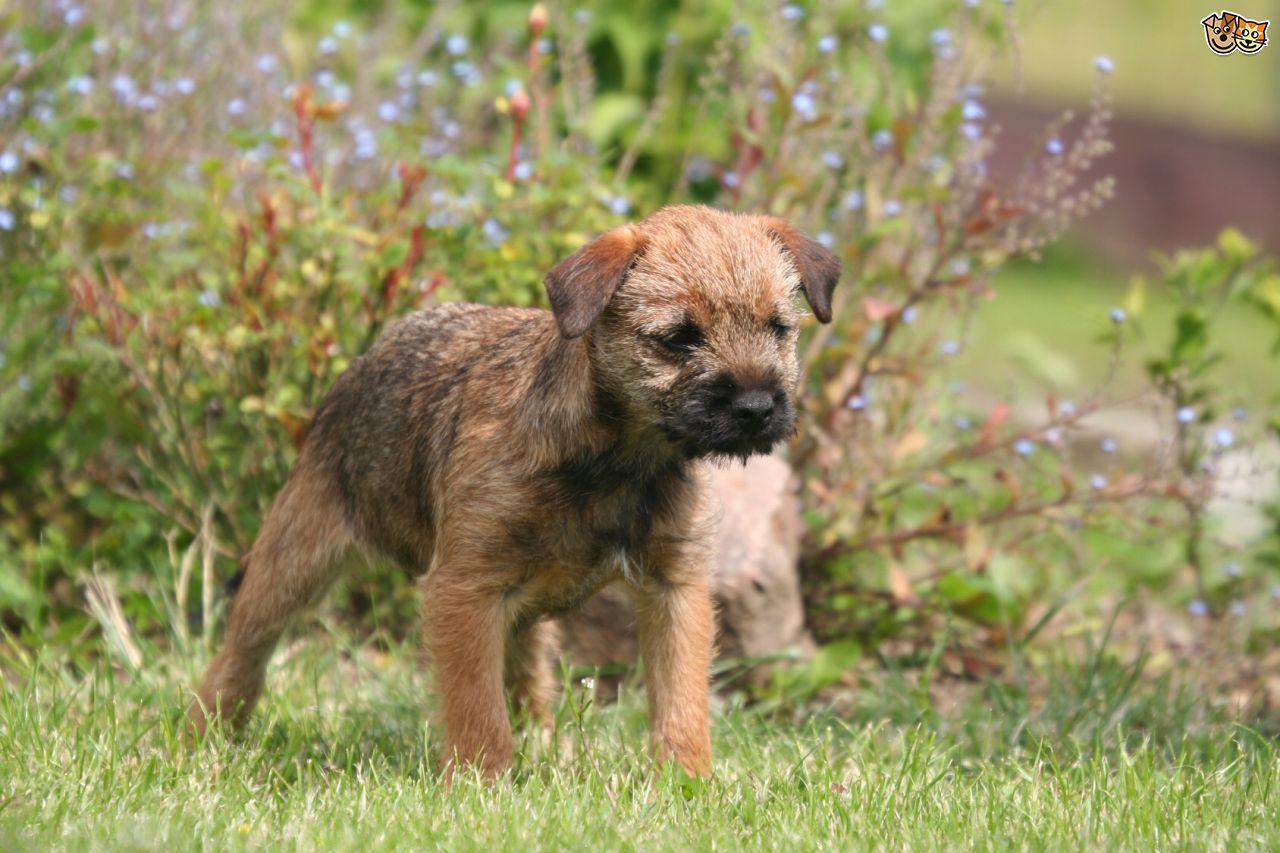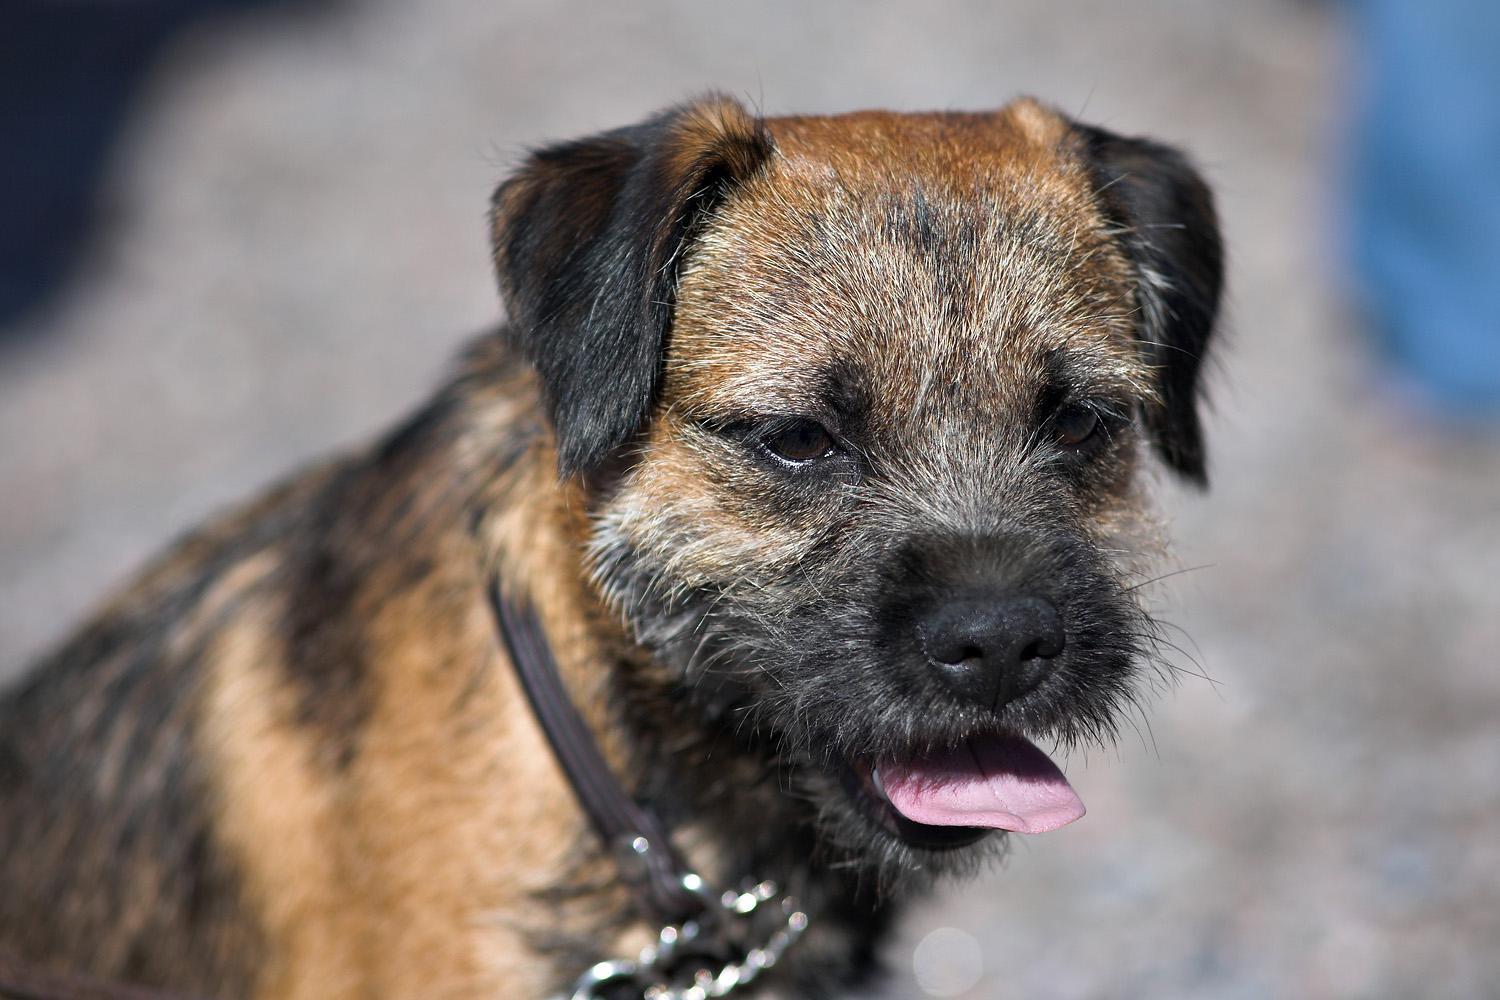The first image is the image on the left, the second image is the image on the right. Examine the images to the left and right. Is the description "All images show one dog that is standing." accurate? Answer yes or no. No. The first image is the image on the left, the second image is the image on the right. Evaluate the accuracy of this statement regarding the images: "One of the dogs has its tongue visible without its teeth showing.". Is it true? Answer yes or no. Yes. 